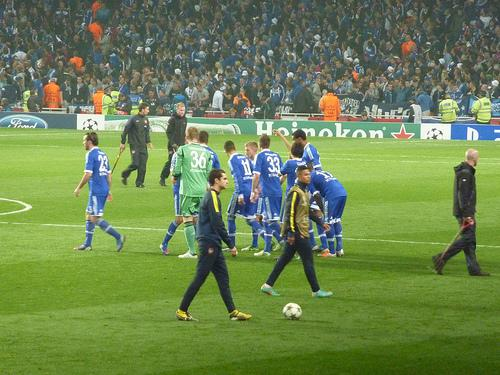Question: where are they playing?
Choices:
A. A playground.
B. A school yard.
C. A park.
D. A field.
Answer with the letter. Answer: D Question: why are the players grouped together?
Choices:
A. To talk.
B. To strategize.
C. The game is not being played.
D. To rest.
Answer with the letter. Answer: C 